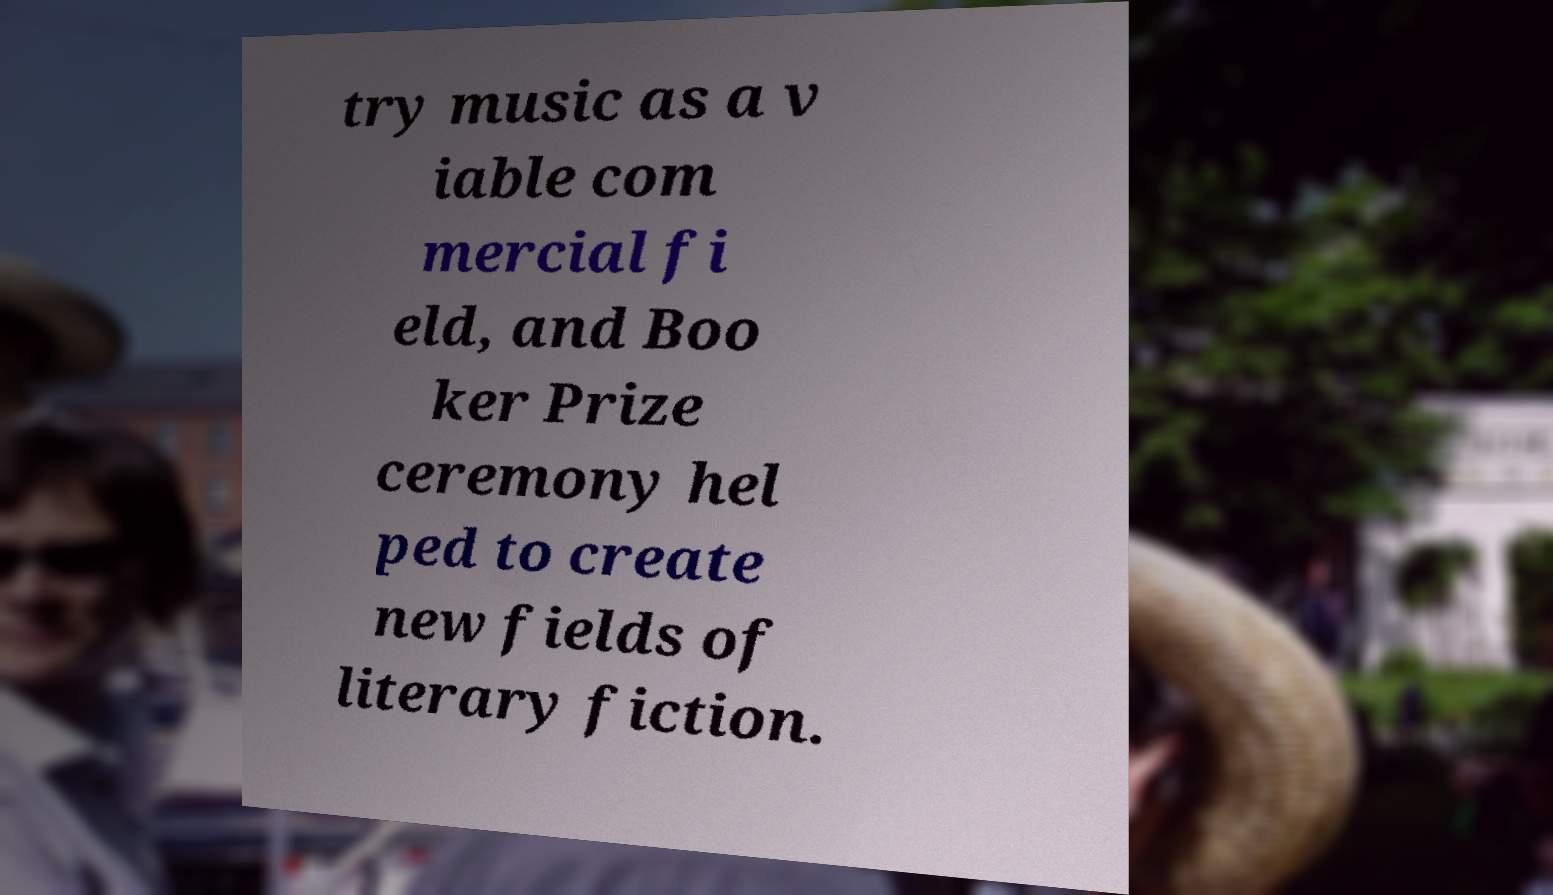Can you accurately transcribe the text from the provided image for me? try music as a v iable com mercial fi eld, and Boo ker Prize ceremony hel ped to create new fields of literary fiction. 